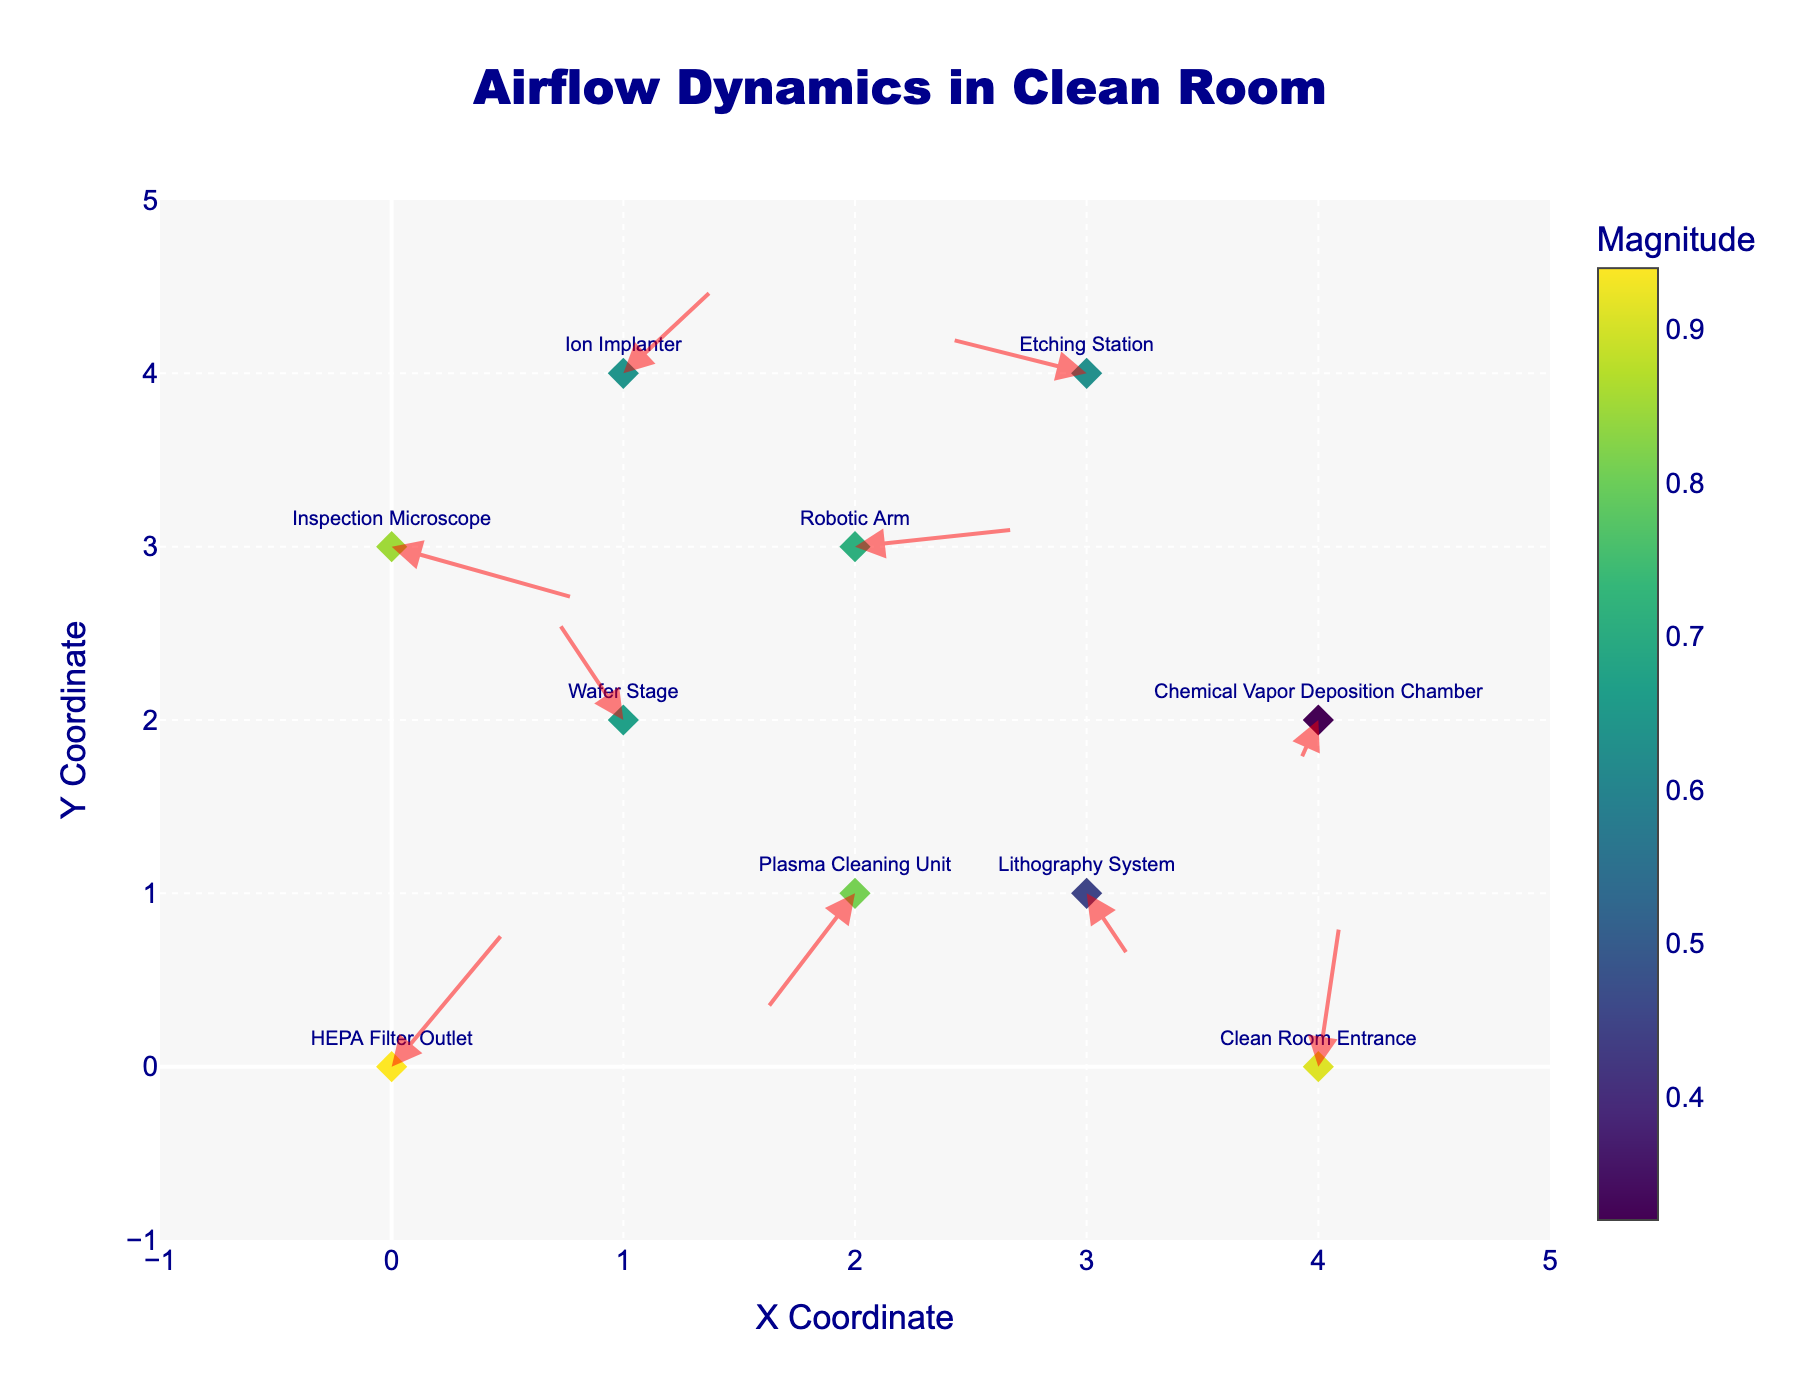Which location has the highest magnitude? The figure displays the magnitude of airflow as the color of the markers. The marker at (0, 0), representing the "HEPA Filter Outlet," has the highest magnitude with a darker color.
Answer: HEPA Filter Outlet What is the title of the plot? The title is located at the top center of the plot and reads "Airflow Dynamics in Clean Room".
Answer: Airflow Dynamics in Clean Room What are the coordinates of the inspection microscope's location? The inspection microscope is labeled in the plot and its coordinates are displayed next to the label.
Answer: (0, 3) What is the average magnitude of airflow dynamics across all locations? Sum the magnitudes (0.94, 0.67, 0.45, 0.71, 0.32, 0.64, 0.63, 0.91, 0.81, 0.85) and then divide by the number of locations, which is 10: (0.94 + 0.67 + 0.45 + 0.71 + 0.32 + 0.64 + 0.63 + 0.91 + 0.81 + 0.85) / 10 = 6.93 / 10 = 0.693
Answer: 0.693 Which location has the lowest airflow magnitude? The color bar indicates airflow magnitude, and the marker with the lightest color is at (4, 2), representing the "Chemical Vapor Deposition Chamber" with a value of 0.32.
Answer: Chemical Vapor Deposition Chamber How many locations have a magnitude greater than 0.7? From the color scale and labels, we identify HEPA Filter Outlet (0.94), Robotic Arm (0.71), Clean Room Entrance (0.91), Plasma Cleaning Unit (0.81), and Inspection Microscope (0.85), making this a total of 5 locations.
Answer: 5 Which direction is the airflow pointing at the Lithography System? The arrow at the Lithography System (3, 1) points downwards and slightly to the right (with u = 0.2 and v = -0.4), indicating a downward direction.
Answer: Downwards and slightly to the right Are more locations experiencing airflow in the positive x-axis direction than the negative x-axis direction? Count the number of vectors with positive 'u' components (positive x-direction): 4 (HEPA Filter Outlet, Lithography System, Robotic Arm, Clean Room Entrance). Count vectors with negative 'u' components (negative x-direction): 3 (Wafer Stage, Plasma Cleaning Unit, Etching Station).
Answer: No Between the Plasma Cleaning Unit and the Ion Implanter, which has a higher magnitude? The magnitudes are provided directly in the plot: Plasma Cleaning Unit (0.81) and Ion Implanter (0.64).
Answer: Plasma Cleaning Unit What is the range of x-coordinates shown in the plot? The x-axis is labeled with the range, which extends from -1 to 5.
Answer: -1 to 5 